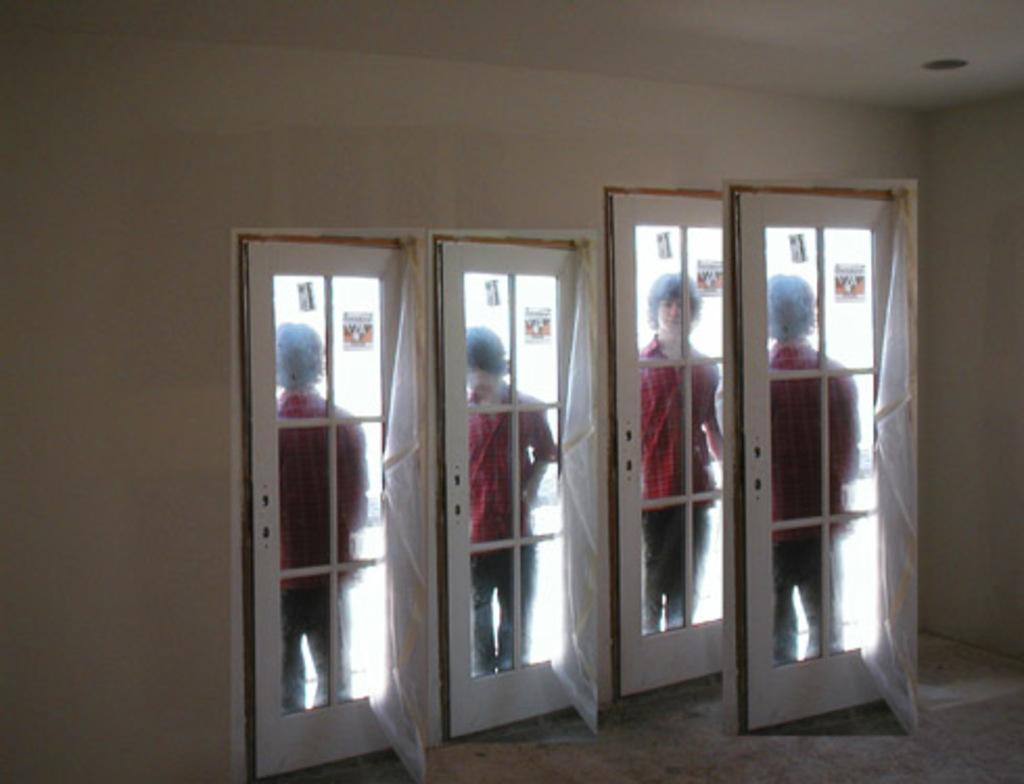What is happening in the image with the person? The image is edited to show the person in different positions. What is in front of the person? There is a door in front of the person. What is behind the door? There is a wall behind the door. What type of approval does the person need to enter the fictional world in the image? There is no fictional world or approval process mentioned in the image; it simply shows a person in different positions with a door and wall. 